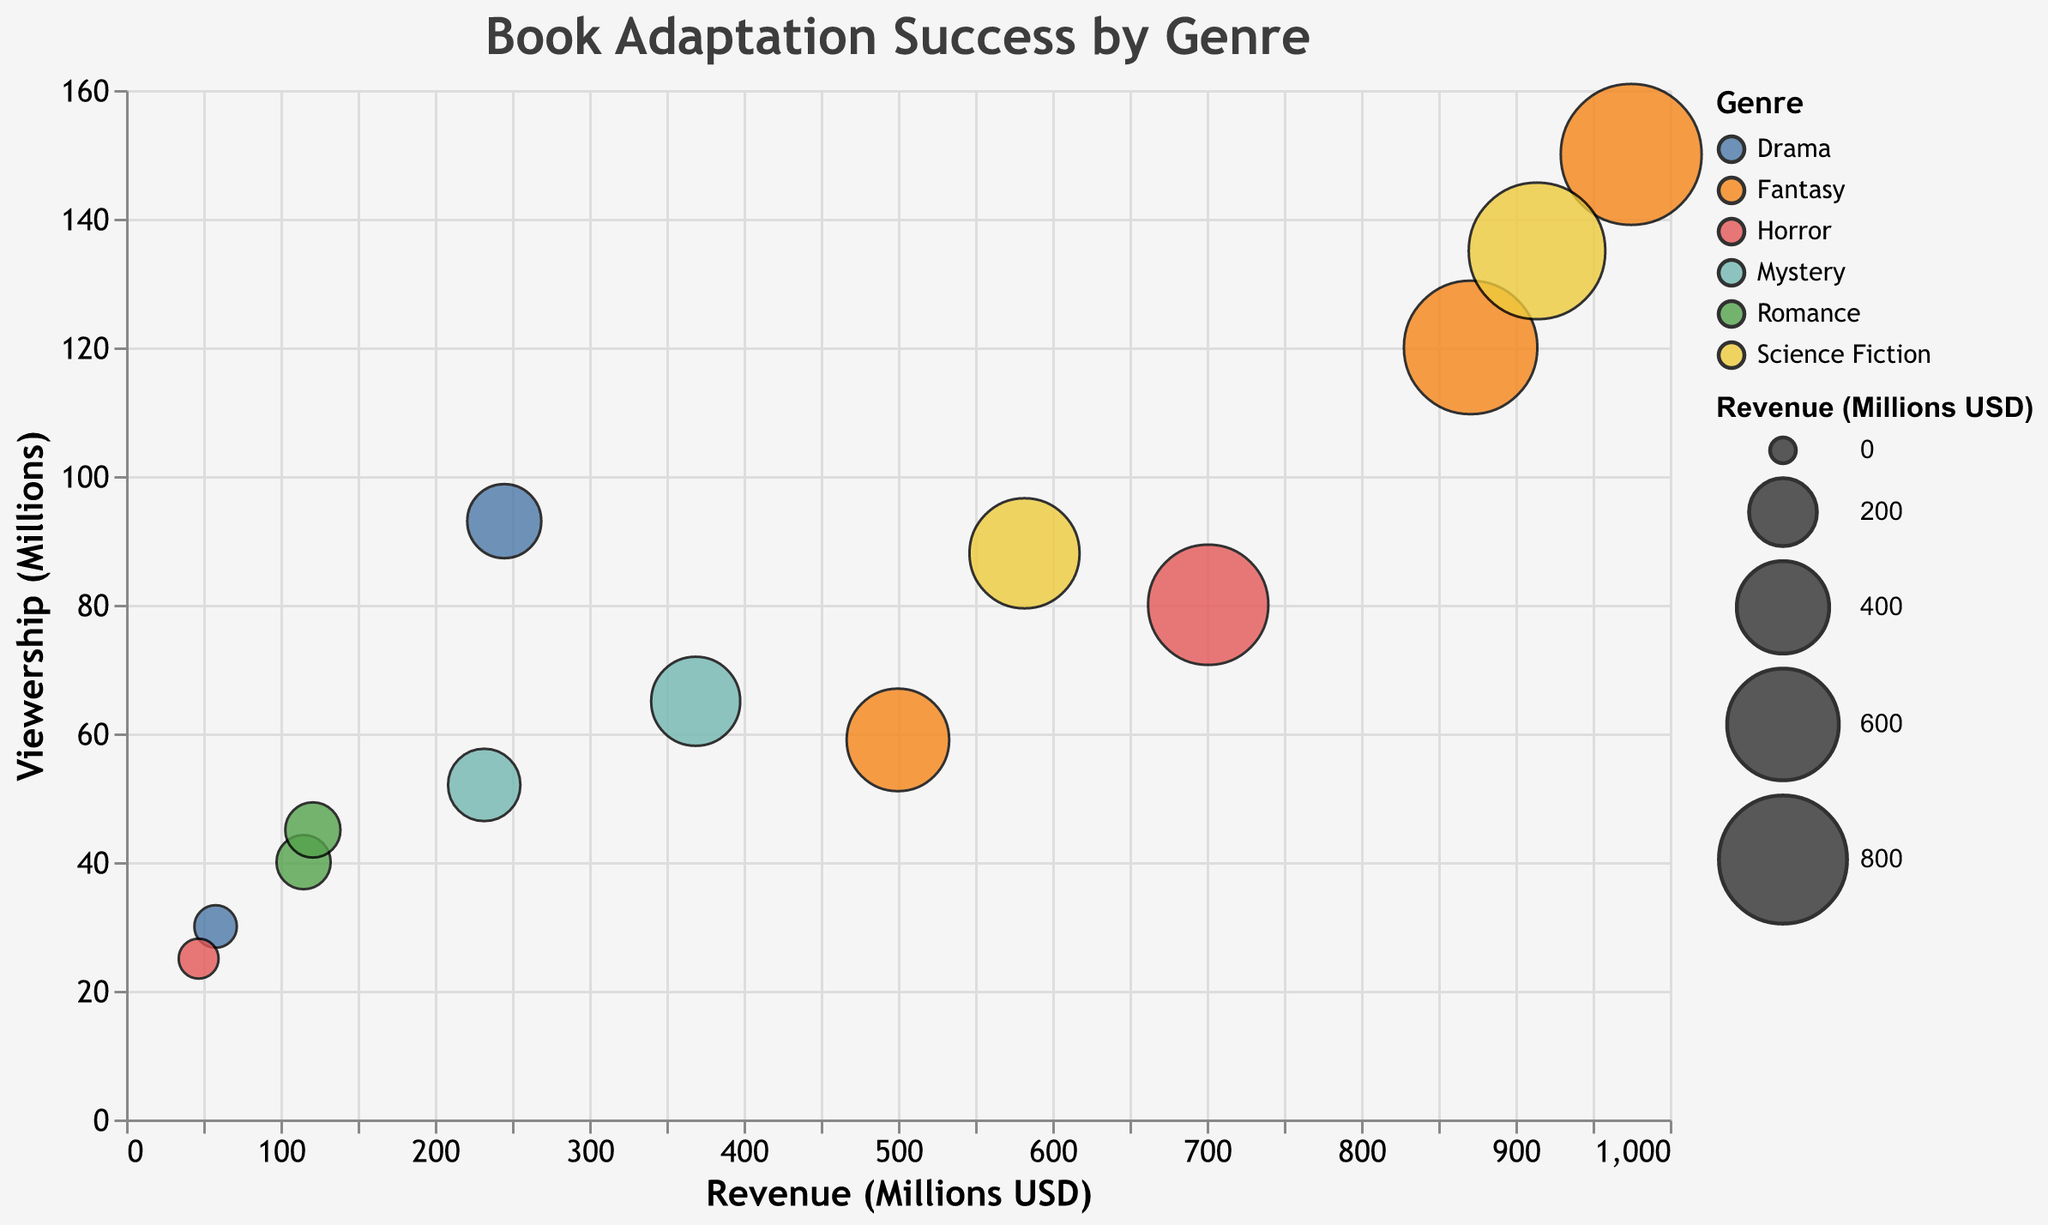What is the title of the figure? The figure's title is prominently displayed at the top and reads "Book Adaptation Success by Genre."
Answer: Book Adaptation Success by Genre Which genre has the highest revenue and what is the book title? The genre with the highest revenue is Fantasy, specifically the book "Harry Potter and the Philosopher's Stone" with a revenue of 975 million USD.
Answer: Fantasy, Harry Potter and the Philosopher's Stone How many genres are represented in the figure, and what are they? By looking at the distinct colors and the legend, there are six genres represented: Fantasy, Science Fiction, Romance, Mystery, Drama, and Horror.
Answer: Six, Fantasy, Science Fiction, Romance, Mystery, Drama, Horror Which director has the most entries in the bubble chart, and how many entries do they have? Steven Spielberg and David Fincher each have two entries under Science Fiction and Mystery genres, respectively. This can be verified by looking at the tooltip information by hovering over the data points.
Answer: Steven Spielberg and David Fincher, 2 entries each Which book adaptation has the highest viewership and what is the viewership count? The book adaptation with the highest viewership is "Harry Potter and the Philosopher's Stone" with a viewership count of 150 million.
Answer: Harry Potter and the Philosopher's Stone, 150 million Among the genres, which one has the book adaptation with the lowest revenue, and what is the title of that book? By looking at the x-axis and the size of the bubbles, the genre with the lowest revenue is Horror, with "The Shining" having a revenue of 47 million USD.
Answer: Horror, The Shining Compare the total revenue of Science Fiction and Fantasy adaptations. Which genre generates more revenue, and what is the difference? Sum the revenue for each genre: Science Fiction (914 + 582) = 1496 million USD, Fantasy (975 + 871 + 500) = 2346 million USD. Fantasy generates more revenue by (2346 - 1496) = 850 million USD.
Answer: Fantasy, 850 million USD Which book adaptation in the Romance genre has a higher viewership, and by how much? "Pride and Prejudice" has a viewership of 45 million, while "The Notebook" has 40 million. Therefore, "Pride and Prejudice" has a higher viewership by (45 - 40) = 5 million.
Answer: Pride and Prejudice, 5 million Which genre has the most balanced (closest) values between revenue and viewership, and what book represents this balance? By comparing both axis values for each genre, the book "Jurassic Park" in the Science Fiction genre closely balances revenue (914 million USD) and viewership (135 million) since both values are relatively high and closer.
Answer: Science Fiction, Jurassic Park 